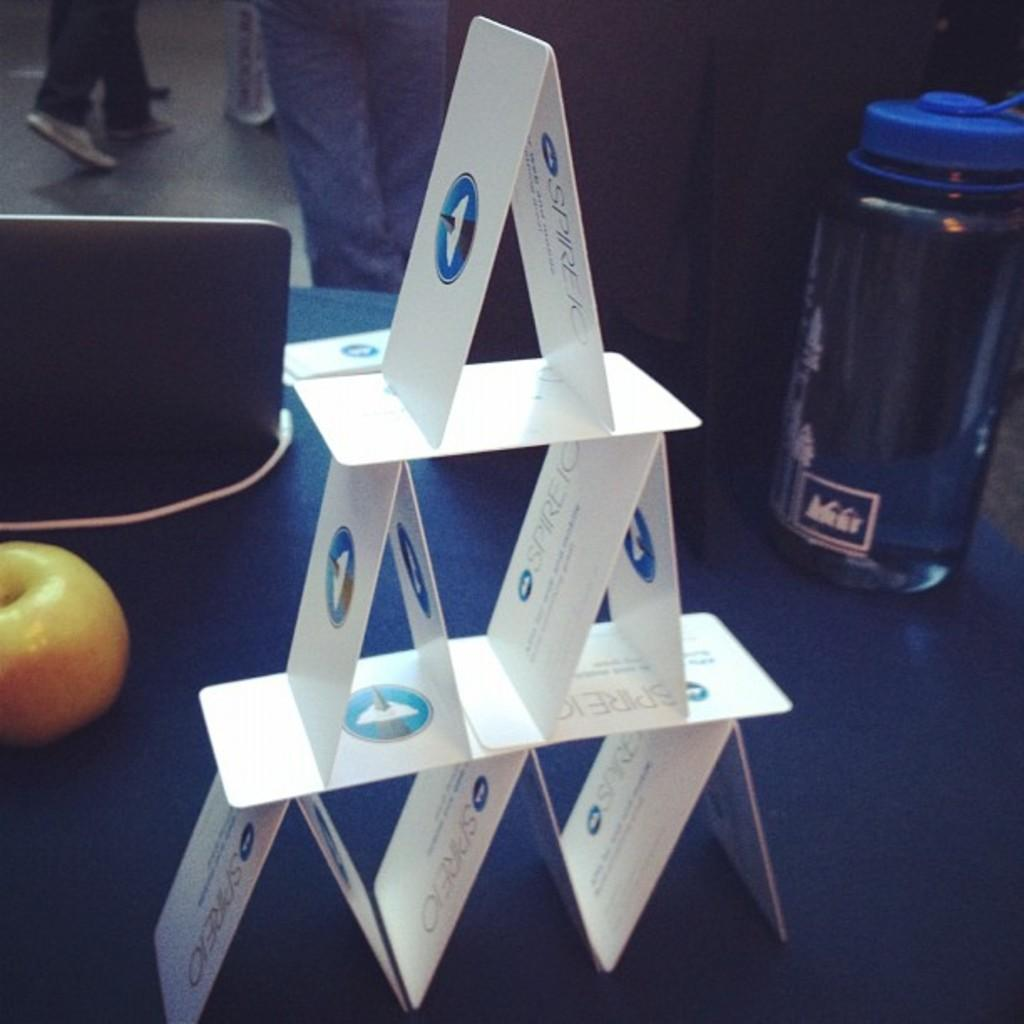What is the arrangement of the cards on the table in the image? The cards are arranged in the form of a building on the table. What other objects can be seen on the table? There is a jar in the image. What type of food items are present in the image? There are fruits in the image. What electronic device is visible in the image? There is a tablet in the image. Can you describe the person in the background of the image? There is a person standing in the background of the image. What type of cork can be seen floating in the jar in the image? There is no cork present in the image; the jar does not contain any liquid. 